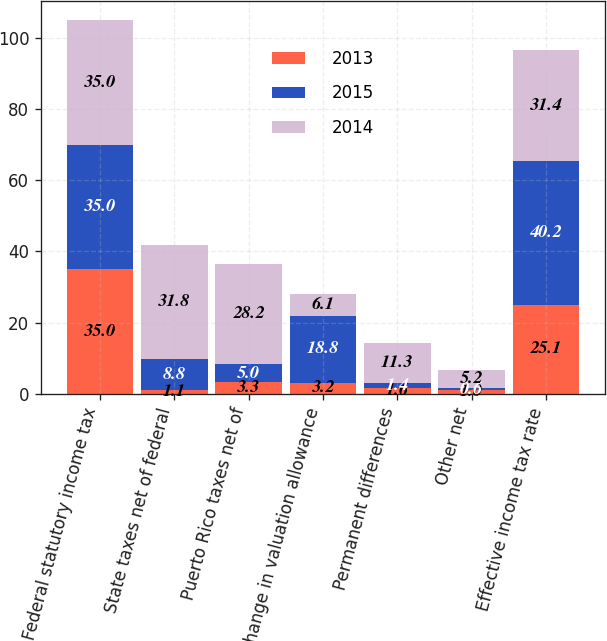Convert chart. <chart><loc_0><loc_0><loc_500><loc_500><stacked_bar_chart><ecel><fcel>Federal statutory income tax<fcel>State taxes net of federal<fcel>Puerto Rico taxes net of<fcel>Change in valuation allowance<fcel>Permanent differences<fcel>Other net<fcel>Effective income tax rate<nl><fcel>2013<fcel>35<fcel>1.1<fcel>3.3<fcel>3.2<fcel>1.6<fcel>1<fcel>25.1<nl><fcel>2015<fcel>35<fcel>8.8<fcel>5<fcel>18.8<fcel>1.4<fcel>0.6<fcel>40.2<nl><fcel>2014<fcel>35<fcel>31.8<fcel>28.2<fcel>6.1<fcel>11.3<fcel>5.2<fcel>31.4<nl></chart> 